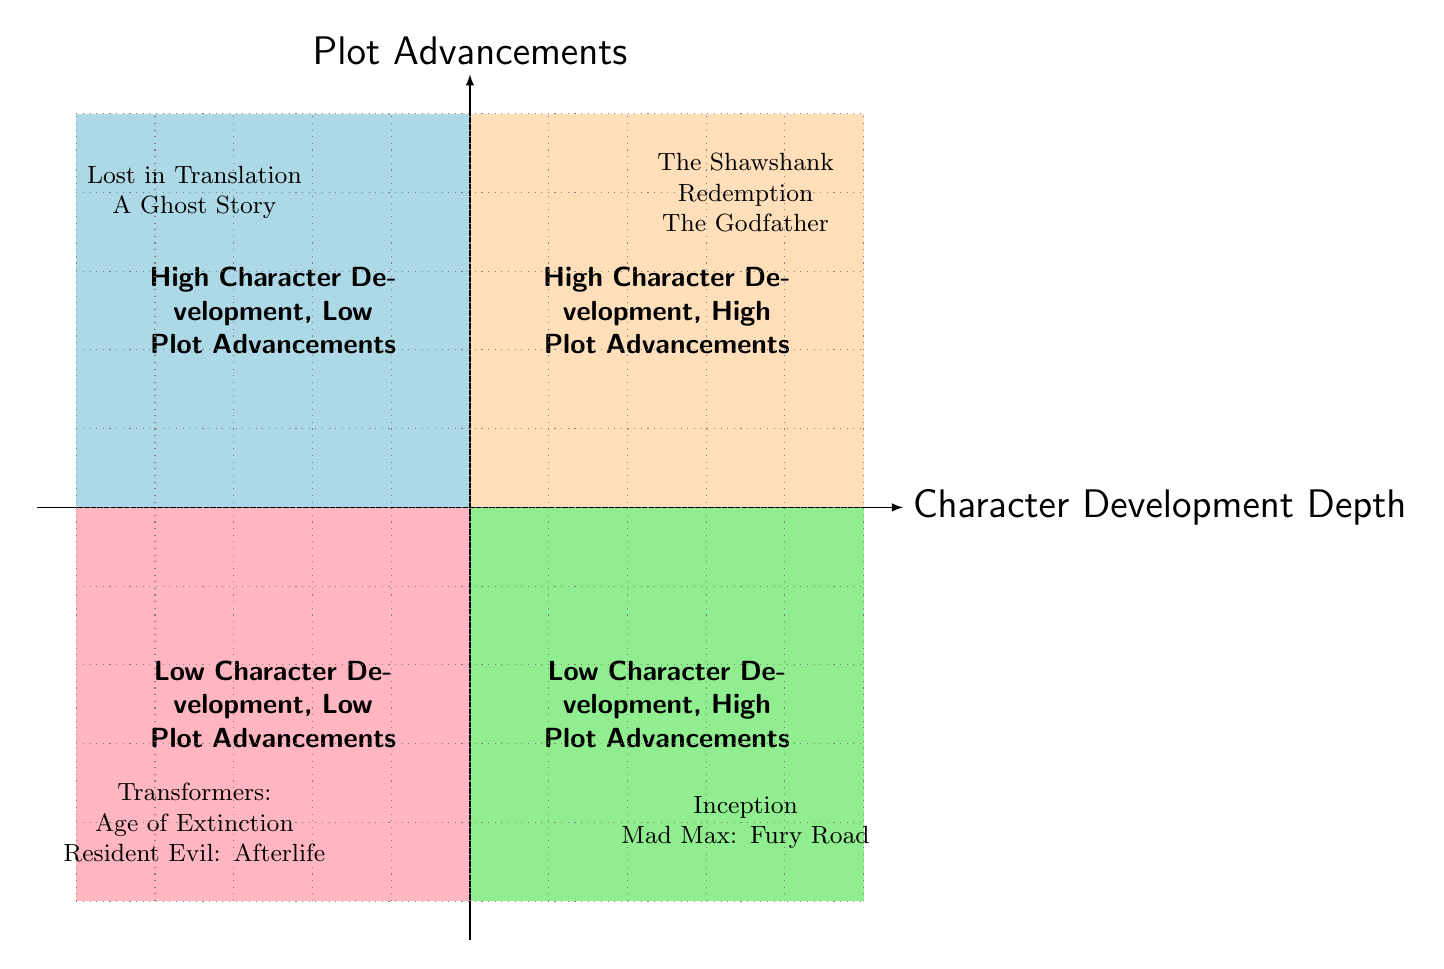What movies are in the High Character Development, High Plot Advancements quadrant? The diagram indicates that the movies in this quadrant are "The Shawshank Redemption" and "The Godfather." This data is found in the section representing high character development along with significant plot advancements.
Answer: The Shawshank Redemption, The Godfather How many quadrants are depicted in the diagram? The diagram features four quadrants, which categorize the relationship between character development depth and plot advancements. Each quadrant is labeled according to their characteristics.
Answer: Four Which movie has minimal character backstory and is categorized as Low Character Development, High Plot Advancements? "Mad Max: Fury Road" is identified in this quadrant, which emphasizes high levels of plot advancement with minimal character development. This title is located in the quadrant bottom right.
Answer: Mad Max: Fury Road What is the primary focus of the movies in the High Character Development, Low Plot Advancements quadrant? The movies in this quadrant, including "Lost in Translation" and "A Ghost Story," focus primarily on character exploration and emotional depth with a minimal plot. This can be inferred from their respective summaries provided.
Answer: Character exploration Which quadrant contains movies with both low character development and low plot advancements? The quadrant that encompasses both low character development and low plot advancements is located in the bottom left of the diagram. This quadrant lists "Transformers: Age of Extinction" and "Resident Evil: Afterlife."
Answer: Low Character Development, Low Plot Advancements Explain the relationship between "Inception" and its quadrant designation. "Inception" is categorized under Low Character Development, High Plot Advancements. The movie presents a complex heist plot that is rich with twists while providing only basic exploration of the main character's emotional state. Thus, it exemplifies high plot advancements with lower emphasis on character depth.
Answer: Low Character Development, High Plot Advancements Which movies illustrate high character development and have minimalistic plots? "Lost in Translation" and "A Ghost Story” are highlighted here, as they are in the High Character Development, Low Plot Advancements quadrant. The focus on deep emotional narratives takes precedence over the progression of plot events.
Answer: Lost in Translation, A Ghost Story How does "The Godfather" exemplify high plot advancements? "The Godfather" is representative of high plot advancements through its complex narrative involving mafia power dynamics, familial betrayal, and character arcs that intricately weave together to advance the story. This is the essence of its plot as depicted in the high advancements quadrant.
Answer: Complex mafia power shifts, family saga, and betrayal 